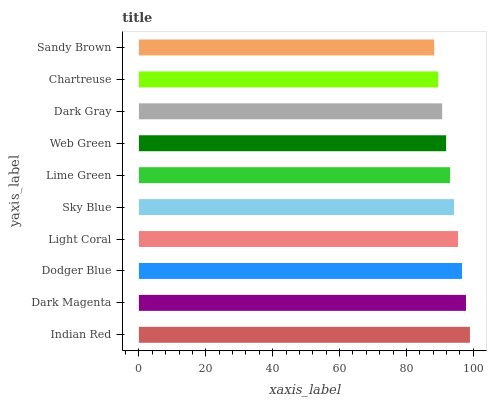Is Sandy Brown the minimum?
Answer yes or no. Yes. Is Indian Red the maximum?
Answer yes or no. Yes. Is Dark Magenta the minimum?
Answer yes or no. No. Is Dark Magenta the maximum?
Answer yes or no. No. Is Indian Red greater than Dark Magenta?
Answer yes or no. Yes. Is Dark Magenta less than Indian Red?
Answer yes or no. Yes. Is Dark Magenta greater than Indian Red?
Answer yes or no. No. Is Indian Red less than Dark Magenta?
Answer yes or no. No. Is Sky Blue the high median?
Answer yes or no. Yes. Is Lime Green the low median?
Answer yes or no. Yes. Is Lime Green the high median?
Answer yes or no. No. Is Dark Magenta the low median?
Answer yes or no. No. 